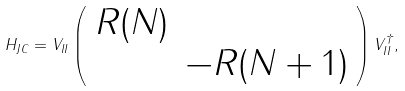<formula> <loc_0><loc_0><loc_500><loc_500>H _ { J C } = V _ { I I } \left ( \begin{array} { c c } R ( N ) & \\ & - R ( N + 1 ) \end{array} \right ) V _ { I I } ^ { \dagger } ,</formula> 